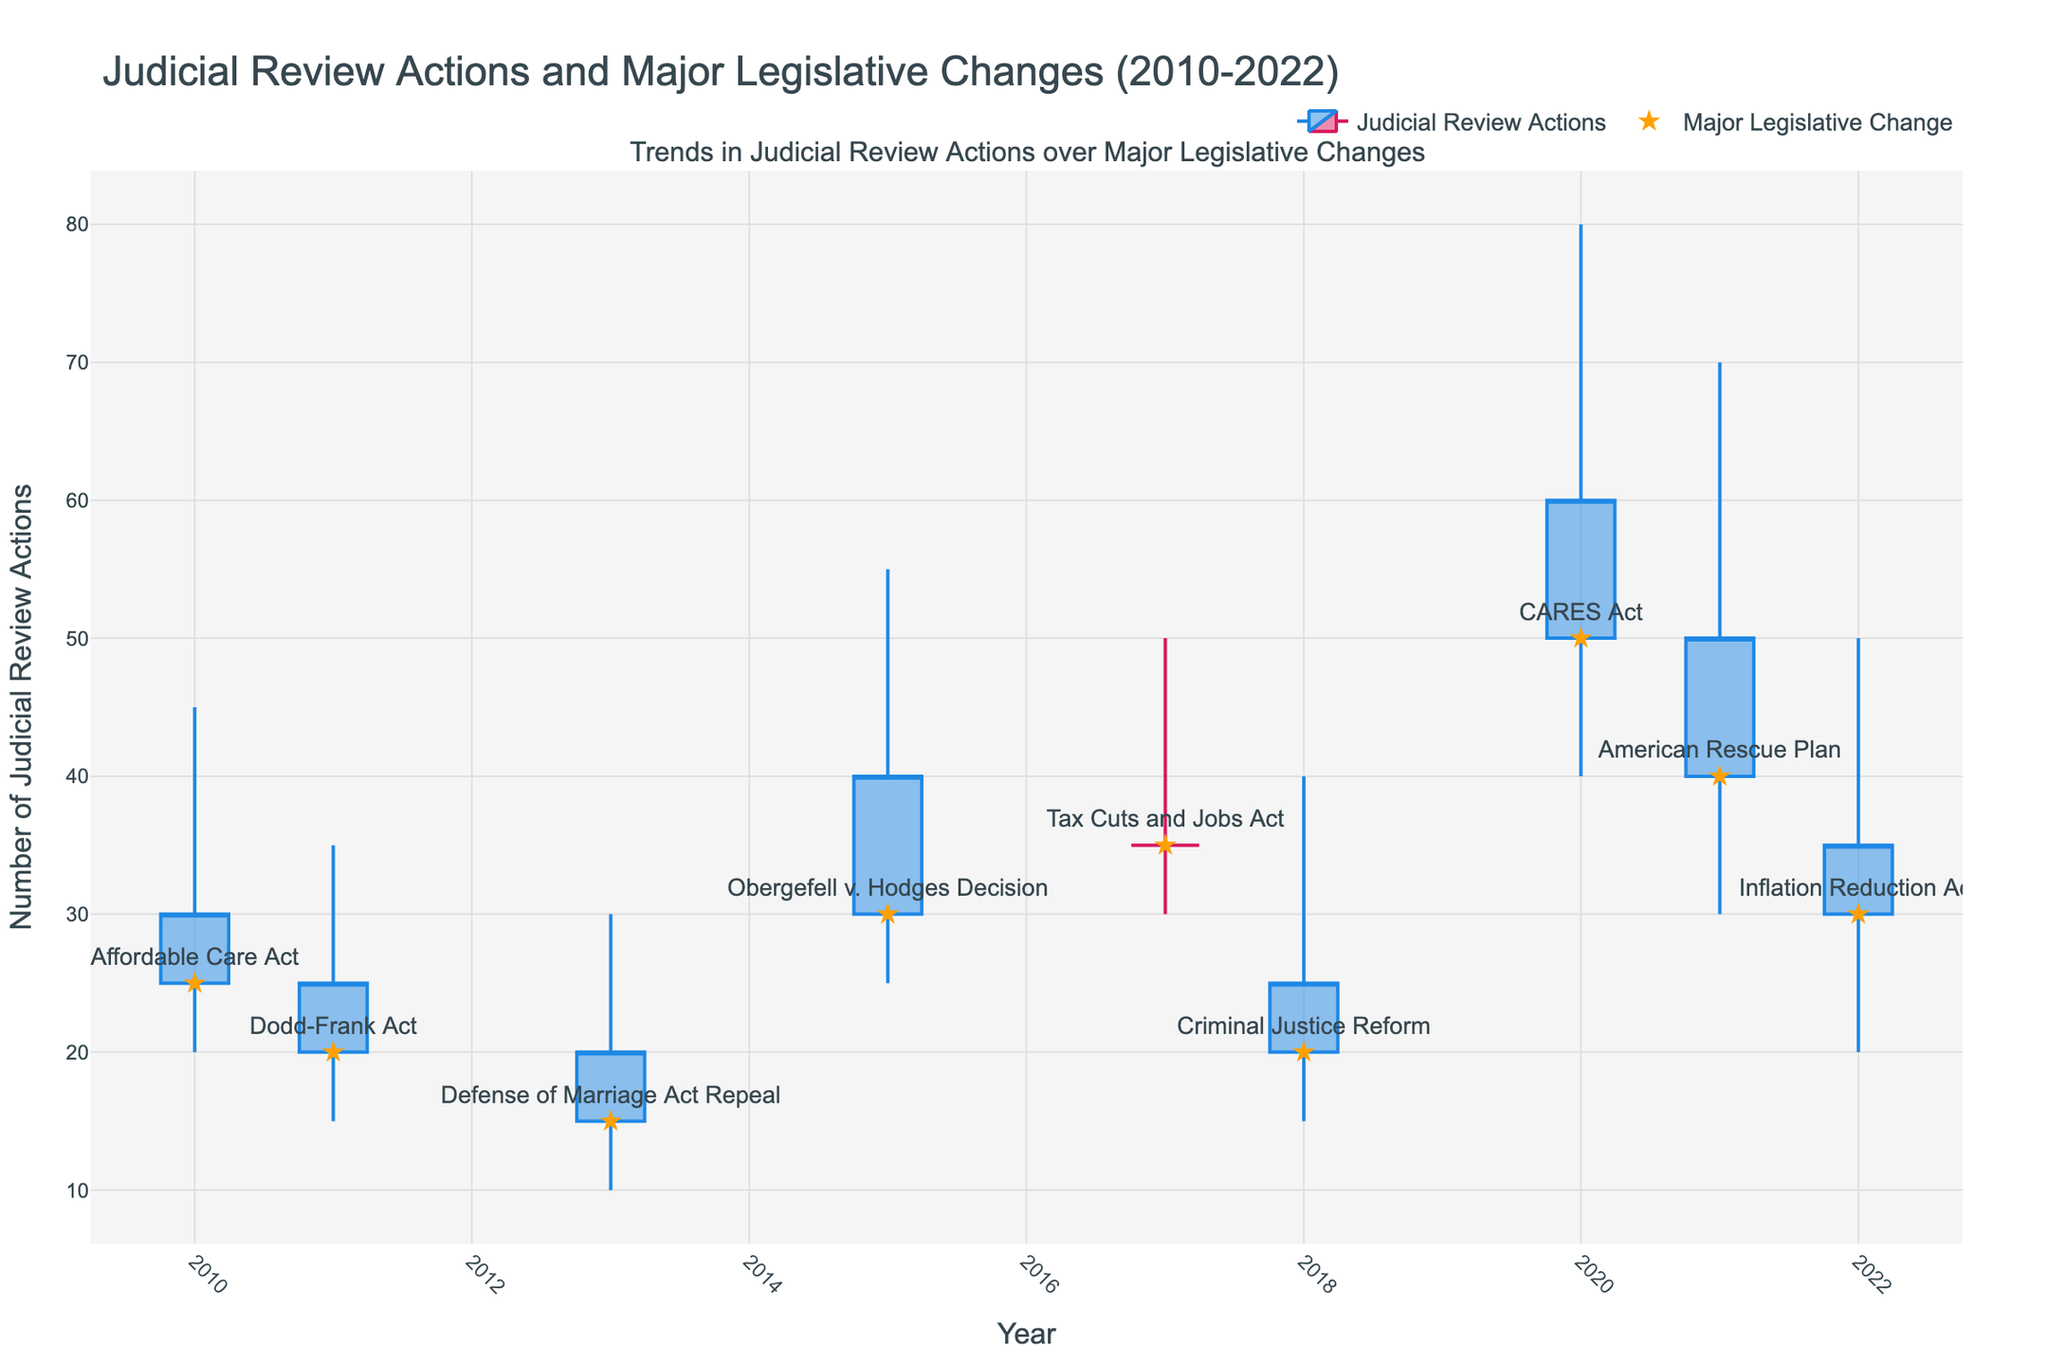what's the title of the chart? The title is usually located at the top of the chart in a larger font.
Answer: Judicial Review Actions and Major Legislative Changes (2010-2022) what's the first year shown on the x-axis? The x-axis is labeled with years. By examining the leftmost label on the x-axis, we can identify the first year.
Answer: 2010 how many major legislative changes are marked in the plot? Major legislative changes are indicated by star markers on the plot. By counting the number of stars, we can determine the answer.
Answer: 9 what's the highest number of judicial review actions recorded in this period? To find the highest value, look at the highest point of vertical lines (high values) in the candlestick plot.
Answer: 80 what year shows the highest closing value of judicial review actions? The closing values are indicated by the end of the candles. The highest closing value is where the top of the body reaches its peak. Identify the corresponding year.
Answer: 2020 which year had the lowest opening value for judicial review actions? The opening values are the starting points of the candle bodies. The year with the lowest initiation point among these has the lowest opening value.
Answer: 2013 how much did judicial review actions increase from the open to the close in 2015? Subtract the opening value from the closing value for the year 2015.
Answer: 10 (40 - 30 = 10) which years had a greater closing value of judicial review actions compared to their opening value? Examine each year; if the close value is greater than the open value, it indicates an increase. List those years.
Answer: 2010, 2015, 2020, 2021 what is the median opening value across all years? First, list all opening values: 25, 20, 15, 30, 35, 20, 50, 40, 30. To find the median, order these values and identify the middle one.
Answer: 30 in which years did the judicial review actions decrease from open to close? Analyzing each candlestick, if the closing value is lower than the opening value, it indicates a decrease. Identify those years.
Answer: 2011, 2013, 2017, 2018, 2022 